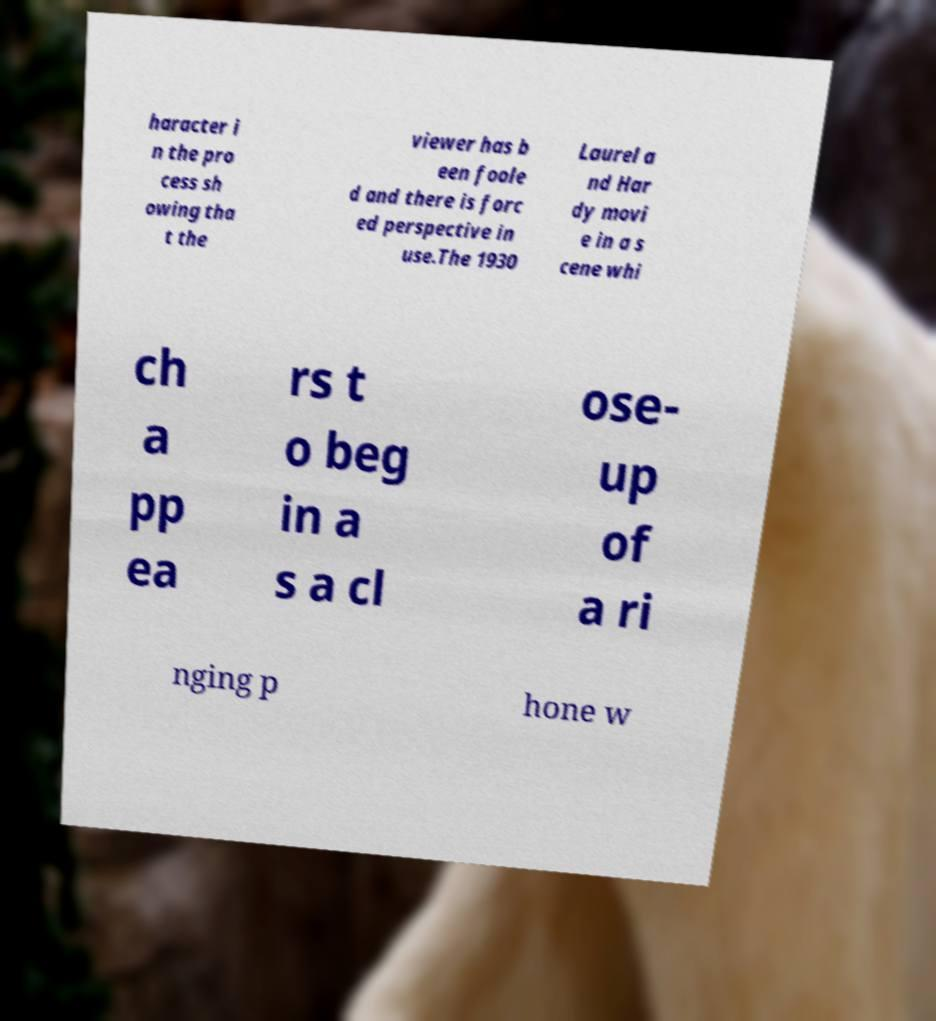There's text embedded in this image that I need extracted. Can you transcribe it verbatim? haracter i n the pro cess sh owing tha t the viewer has b een foole d and there is forc ed perspective in use.The 1930 Laurel a nd Har dy movi e in a s cene whi ch a pp ea rs t o beg in a s a cl ose- up of a ri nging p hone w 